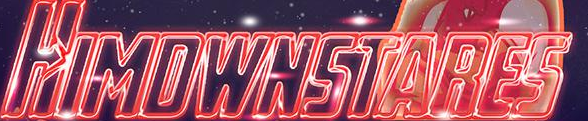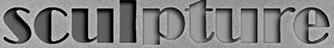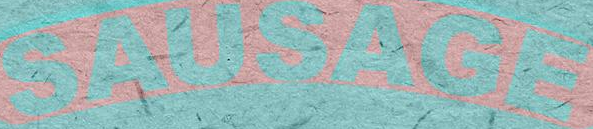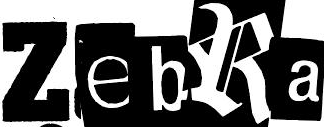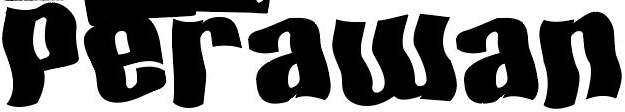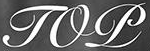What text is displayed in these images sequentially, separated by a semicolon? HIMDWNSTARES; sculpture; SAUSAGE; ZebRa; Perawan; TOP 